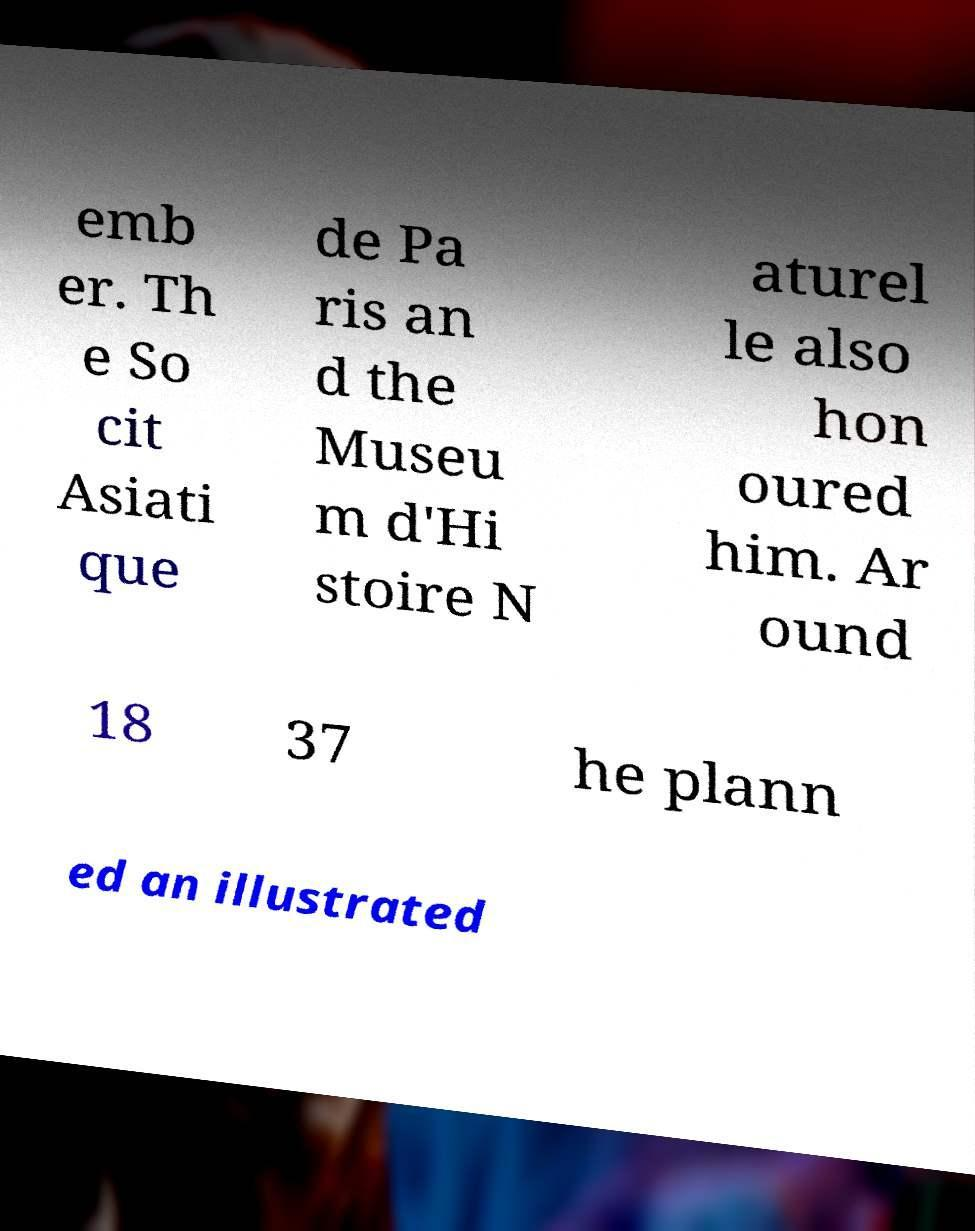Can you accurately transcribe the text from the provided image for me? emb er. Th e So cit Asiati que de Pa ris an d the Museu m d'Hi stoire N aturel le also hon oured him. Ar ound 18 37 he plann ed an illustrated 